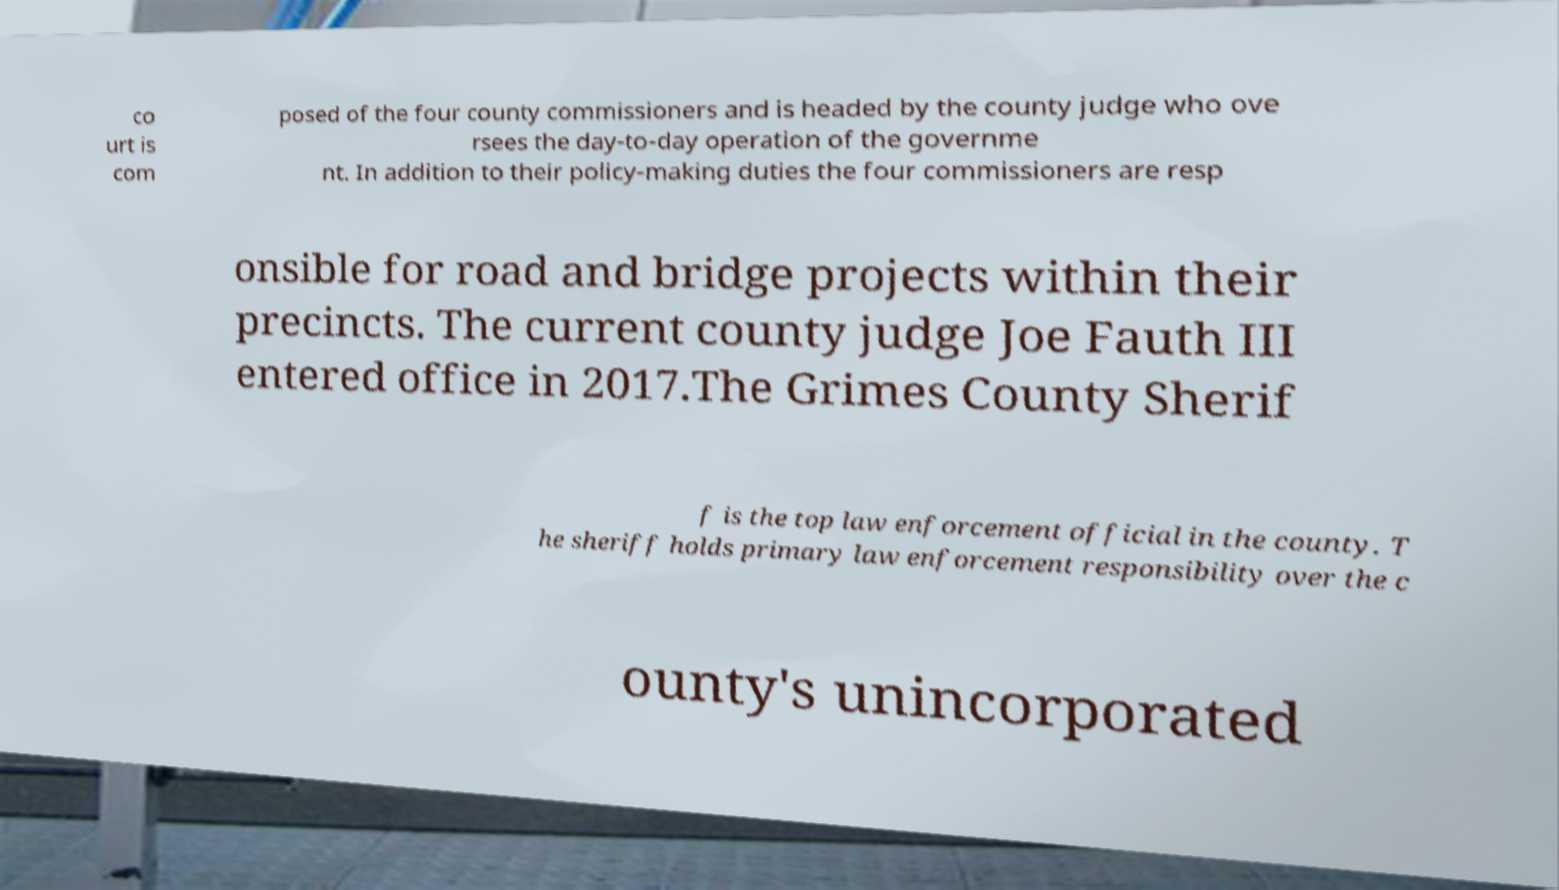Can you accurately transcribe the text from the provided image for me? co urt is com posed of the four county commissioners and is headed by the county judge who ove rsees the day-to-day operation of the governme nt. In addition to their policy-making duties the four commissioners are resp onsible for road and bridge projects within their precincts. The current county judge Joe Fauth III entered office in 2017.The Grimes County Sherif f is the top law enforcement official in the county. T he sheriff holds primary law enforcement responsibility over the c ounty's unincorporated 